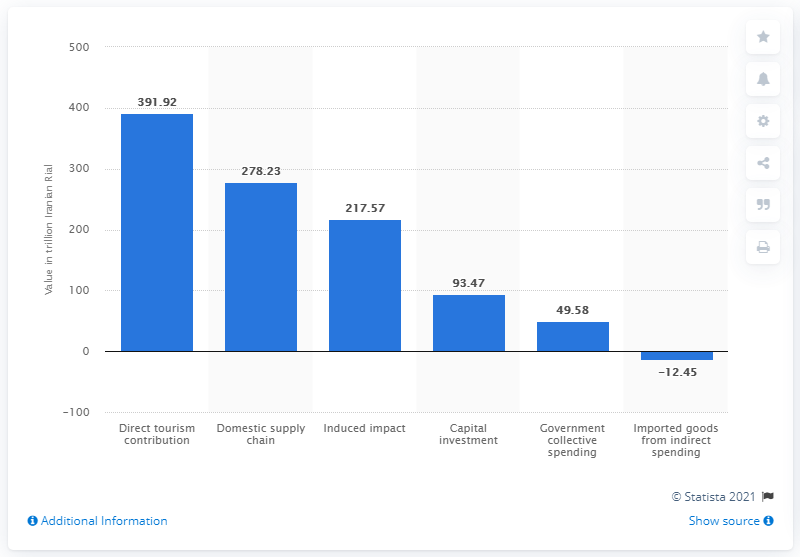Indicate a few pertinent items in this graphic. In 2017, the direct contribution of tourism to Iran's Gross Domestic Product (GDP) was 391.92. The average value of different types of tourism and travel that are regarded as worth over 100 trillion is 295.906666... 